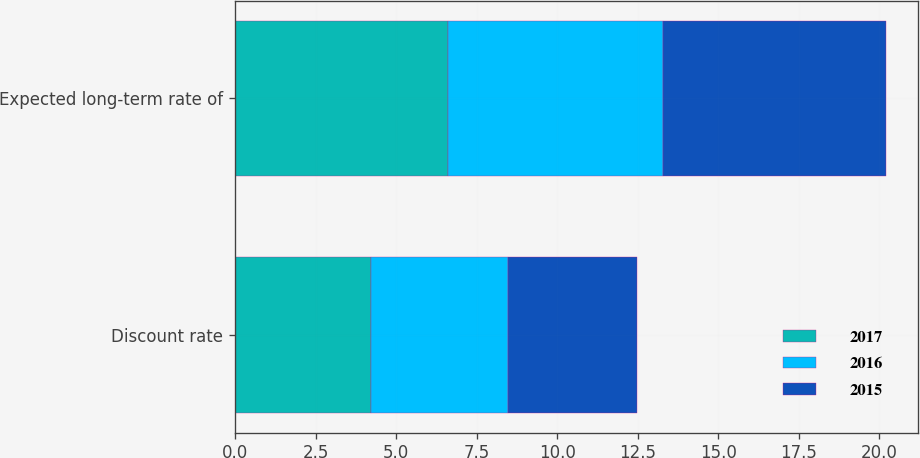<chart> <loc_0><loc_0><loc_500><loc_500><stacked_bar_chart><ecel><fcel>Discount rate<fcel>Expected long-term rate of<nl><fcel>2017<fcel>4.22<fcel>6.6<nl><fcel>2016<fcel>4.25<fcel>6.7<nl><fcel>2015<fcel>4<fcel>6.9<nl></chart> 